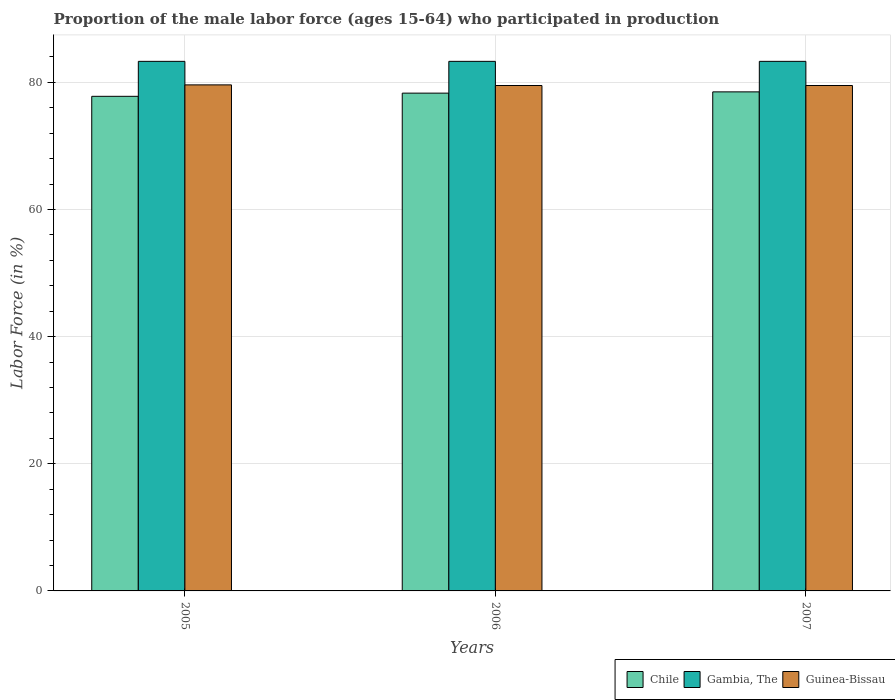How many different coloured bars are there?
Ensure brevity in your answer.  3. How many groups of bars are there?
Your answer should be very brief. 3. Are the number of bars on each tick of the X-axis equal?
Keep it short and to the point. Yes. In how many cases, is the number of bars for a given year not equal to the number of legend labels?
Offer a terse response. 0. What is the proportion of the male labor force who participated in production in Guinea-Bissau in 2007?
Your response must be concise. 79.5. Across all years, what is the maximum proportion of the male labor force who participated in production in Gambia, The?
Your answer should be compact. 83.3. Across all years, what is the minimum proportion of the male labor force who participated in production in Gambia, The?
Your answer should be compact. 83.3. In which year was the proportion of the male labor force who participated in production in Guinea-Bissau minimum?
Your response must be concise. 2006. What is the total proportion of the male labor force who participated in production in Gambia, The in the graph?
Ensure brevity in your answer.  249.9. What is the difference between the proportion of the male labor force who participated in production in Gambia, The in 2006 and that in 2007?
Offer a terse response. 0. What is the difference between the proportion of the male labor force who participated in production in Guinea-Bissau in 2005 and the proportion of the male labor force who participated in production in Gambia, The in 2006?
Provide a succinct answer. -3.7. What is the average proportion of the male labor force who participated in production in Chile per year?
Make the answer very short. 78.2. In the year 2005, what is the difference between the proportion of the male labor force who participated in production in Gambia, The and proportion of the male labor force who participated in production in Chile?
Your response must be concise. 5.5. What is the ratio of the proportion of the male labor force who participated in production in Chile in 2005 to that in 2006?
Give a very brief answer. 0.99. Is the proportion of the male labor force who participated in production in Guinea-Bissau in 2006 less than that in 2007?
Your answer should be compact. No. Is the difference between the proportion of the male labor force who participated in production in Gambia, The in 2006 and 2007 greater than the difference between the proportion of the male labor force who participated in production in Chile in 2006 and 2007?
Your answer should be very brief. Yes. What is the difference between the highest and the second highest proportion of the male labor force who participated in production in Guinea-Bissau?
Offer a very short reply. 0.1. What is the difference between the highest and the lowest proportion of the male labor force who participated in production in Chile?
Provide a short and direct response. 0.7. In how many years, is the proportion of the male labor force who participated in production in Guinea-Bissau greater than the average proportion of the male labor force who participated in production in Guinea-Bissau taken over all years?
Your answer should be compact. 1. Is the sum of the proportion of the male labor force who participated in production in Guinea-Bissau in 2006 and 2007 greater than the maximum proportion of the male labor force who participated in production in Chile across all years?
Make the answer very short. Yes. What does the 2nd bar from the right in 2005 represents?
Your response must be concise. Gambia, The. Is it the case that in every year, the sum of the proportion of the male labor force who participated in production in Gambia, The and proportion of the male labor force who participated in production in Chile is greater than the proportion of the male labor force who participated in production in Guinea-Bissau?
Offer a very short reply. Yes. How many bars are there?
Provide a succinct answer. 9. Are all the bars in the graph horizontal?
Keep it short and to the point. No. Are the values on the major ticks of Y-axis written in scientific E-notation?
Your answer should be very brief. No. Does the graph contain grids?
Offer a terse response. Yes. How many legend labels are there?
Offer a terse response. 3. How are the legend labels stacked?
Make the answer very short. Horizontal. What is the title of the graph?
Offer a very short reply. Proportion of the male labor force (ages 15-64) who participated in production. What is the label or title of the Y-axis?
Your answer should be very brief. Labor Force (in %). What is the Labor Force (in %) in Chile in 2005?
Offer a terse response. 77.8. What is the Labor Force (in %) of Gambia, The in 2005?
Your response must be concise. 83.3. What is the Labor Force (in %) in Guinea-Bissau in 2005?
Your response must be concise. 79.6. What is the Labor Force (in %) of Chile in 2006?
Keep it short and to the point. 78.3. What is the Labor Force (in %) of Gambia, The in 2006?
Your answer should be compact. 83.3. What is the Labor Force (in %) of Guinea-Bissau in 2006?
Offer a very short reply. 79.5. What is the Labor Force (in %) in Chile in 2007?
Give a very brief answer. 78.5. What is the Labor Force (in %) in Gambia, The in 2007?
Your answer should be very brief. 83.3. What is the Labor Force (in %) in Guinea-Bissau in 2007?
Provide a short and direct response. 79.5. Across all years, what is the maximum Labor Force (in %) of Chile?
Offer a terse response. 78.5. Across all years, what is the maximum Labor Force (in %) in Gambia, The?
Offer a very short reply. 83.3. Across all years, what is the maximum Labor Force (in %) of Guinea-Bissau?
Provide a short and direct response. 79.6. Across all years, what is the minimum Labor Force (in %) in Chile?
Keep it short and to the point. 77.8. Across all years, what is the minimum Labor Force (in %) of Gambia, The?
Your answer should be compact. 83.3. Across all years, what is the minimum Labor Force (in %) of Guinea-Bissau?
Your response must be concise. 79.5. What is the total Labor Force (in %) of Chile in the graph?
Ensure brevity in your answer.  234.6. What is the total Labor Force (in %) in Gambia, The in the graph?
Give a very brief answer. 249.9. What is the total Labor Force (in %) of Guinea-Bissau in the graph?
Make the answer very short. 238.6. What is the difference between the Labor Force (in %) of Chile in 2005 and that in 2006?
Provide a short and direct response. -0.5. What is the difference between the Labor Force (in %) in Guinea-Bissau in 2005 and that in 2006?
Make the answer very short. 0.1. What is the difference between the Labor Force (in %) of Gambia, The in 2005 and that in 2007?
Offer a very short reply. 0. What is the difference between the Labor Force (in %) in Guinea-Bissau in 2005 and that in 2007?
Keep it short and to the point. 0.1. What is the difference between the Labor Force (in %) of Chile in 2006 and that in 2007?
Your answer should be compact. -0.2. What is the difference between the Labor Force (in %) in Chile in 2005 and the Labor Force (in %) in Guinea-Bissau in 2006?
Offer a terse response. -1.7. What is the difference between the Labor Force (in %) in Gambia, The in 2005 and the Labor Force (in %) in Guinea-Bissau in 2006?
Give a very brief answer. 3.8. What is the difference between the Labor Force (in %) in Chile in 2005 and the Labor Force (in %) in Guinea-Bissau in 2007?
Keep it short and to the point. -1.7. What is the difference between the Labor Force (in %) in Gambia, The in 2005 and the Labor Force (in %) in Guinea-Bissau in 2007?
Offer a terse response. 3.8. What is the difference between the Labor Force (in %) of Chile in 2006 and the Labor Force (in %) of Gambia, The in 2007?
Your response must be concise. -5. What is the difference between the Labor Force (in %) of Gambia, The in 2006 and the Labor Force (in %) of Guinea-Bissau in 2007?
Offer a very short reply. 3.8. What is the average Labor Force (in %) of Chile per year?
Keep it short and to the point. 78.2. What is the average Labor Force (in %) in Gambia, The per year?
Provide a succinct answer. 83.3. What is the average Labor Force (in %) of Guinea-Bissau per year?
Offer a very short reply. 79.53. In the year 2005, what is the difference between the Labor Force (in %) in Chile and Labor Force (in %) in Gambia, The?
Offer a very short reply. -5.5. In the year 2005, what is the difference between the Labor Force (in %) of Chile and Labor Force (in %) of Guinea-Bissau?
Your answer should be compact. -1.8. In the year 2005, what is the difference between the Labor Force (in %) of Gambia, The and Labor Force (in %) of Guinea-Bissau?
Your response must be concise. 3.7. In the year 2006, what is the difference between the Labor Force (in %) in Chile and Labor Force (in %) in Gambia, The?
Your answer should be compact. -5. In the year 2006, what is the difference between the Labor Force (in %) in Chile and Labor Force (in %) in Guinea-Bissau?
Provide a succinct answer. -1.2. In the year 2006, what is the difference between the Labor Force (in %) in Gambia, The and Labor Force (in %) in Guinea-Bissau?
Keep it short and to the point. 3.8. In the year 2007, what is the difference between the Labor Force (in %) of Chile and Labor Force (in %) of Gambia, The?
Provide a succinct answer. -4.8. In the year 2007, what is the difference between the Labor Force (in %) in Chile and Labor Force (in %) in Guinea-Bissau?
Ensure brevity in your answer.  -1. What is the ratio of the Labor Force (in %) of Chile in 2006 to that in 2007?
Your answer should be very brief. 1. What is the ratio of the Labor Force (in %) of Gambia, The in 2006 to that in 2007?
Your answer should be very brief. 1. What is the ratio of the Labor Force (in %) of Guinea-Bissau in 2006 to that in 2007?
Provide a short and direct response. 1. What is the difference between the highest and the second highest Labor Force (in %) of Gambia, The?
Provide a succinct answer. 0. 